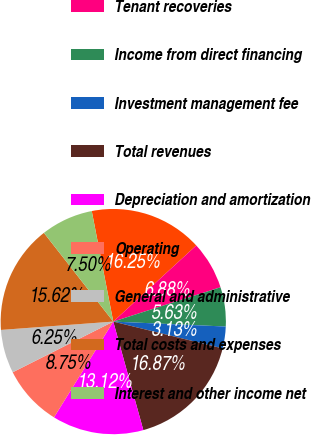Convert chart. <chart><loc_0><loc_0><loc_500><loc_500><pie_chart><fcel>Rental and related revenues<fcel>Tenant recoveries<fcel>Income from direct financing<fcel>Investment management fee<fcel>Total revenues<fcel>Depreciation and amortization<fcel>Operating<fcel>General and administrative<fcel>Total costs and expenses<fcel>Interest and other income net<nl><fcel>16.25%<fcel>6.88%<fcel>5.63%<fcel>3.13%<fcel>16.87%<fcel>13.12%<fcel>8.75%<fcel>6.25%<fcel>15.62%<fcel>7.5%<nl></chart> 